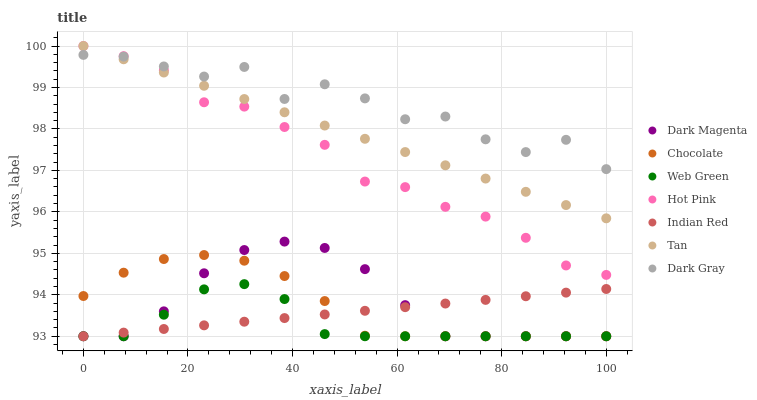Does Web Green have the minimum area under the curve?
Answer yes or no. Yes. Does Dark Gray have the maximum area under the curve?
Answer yes or no. Yes. Does Hot Pink have the minimum area under the curve?
Answer yes or no. No. Does Hot Pink have the maximum area under the curve?
Answer yes or no. No. Is Indian Red the smoothest?
Answer yes or no. Yes. Is Dark Gray the roughest?
Answer yes or no. Yes. Is Hot Pink the smoothest?
Answer yes or no. No. Is Hot Pink the roughest?
Answer yes or no. No. Does Dark Magenta have the lowest value?
Answer yes or no. Yes. Does Hot Pink have the lowest value?
Answer yes or no. No. Does Tan have the highest value?
Answer yes or no. Yes. Does Web Green have the highest value?
Answer yes or no. No. Is Indian Red less than Tan?
Answer yes or no. Yes. Is Tan greater than Indian Red?
Answer yes or no. Yes. Does Web Green intersect Indian Red?
Answer yes or no. Yes. Is Web Green less than Indian Red?
Answer yes or no. No. Is Web Green greater than Indian Red?
Answer yes or no. No. Does Indian Red intersect Tan?
Answer yes or no. No. 